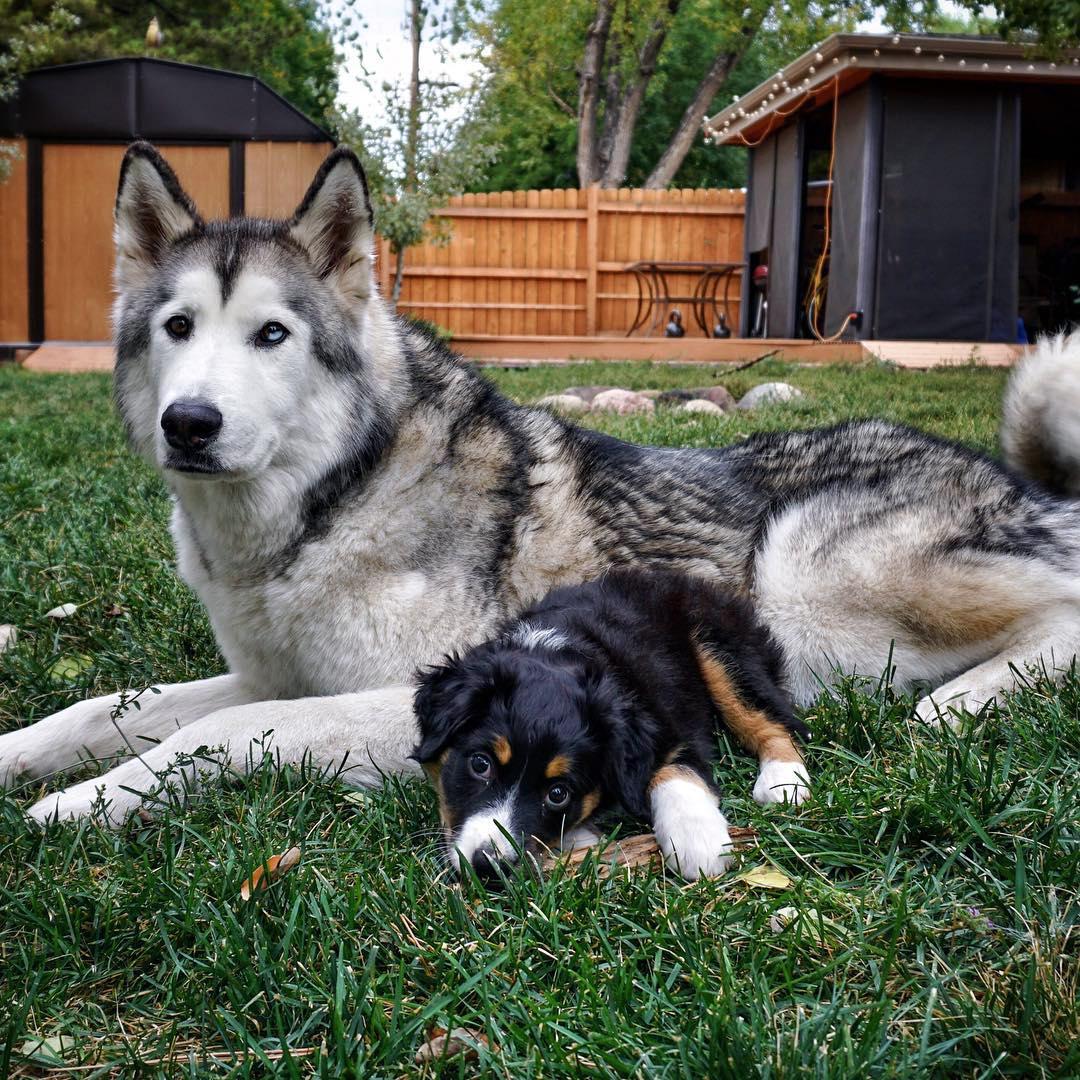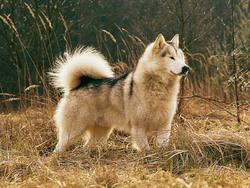The first image is the image on the left, the second image is the image on the right. Analyze the images presented: Is the assertion "In the image on the left, four Malamutes are sitting in the grass in front of a shelter and looking up at something." valid? Answer yes or no. No. 